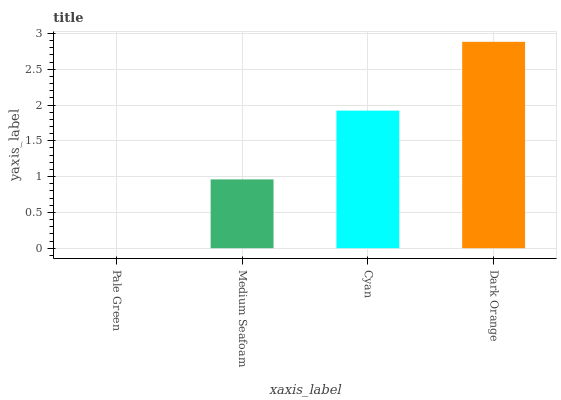Is Pale Green the minimum?
Answer yes or no. Yes. Is Dark Orange the maximum?
Answer yes or no. Yes. Is Medium Seafoam the minimum?
Answer yes or no. No. Is Medium Seafoam the maximum?
Answer yes or no. No. Is Medium Seafoam greater than Pale Green?
Answer yes or no. Yes. Is Pale Green less than Medium Seafoam?
Answer yes or no. Yes. Is Pale Green greater than Medium Seafoam?
Answer yes or no. No. Is Medium Seafoam less than Pale Green?
Answer yes or no. No. Is Cyan the high median?
Answer yes or no. Yes. Is Medium Seafoam the low median?
Answer yes or no. Yes. Is Medium Seafoam the high median?
Answer yes or no. No. Is Dark Orange the low median?
Answer yes or no. No. 